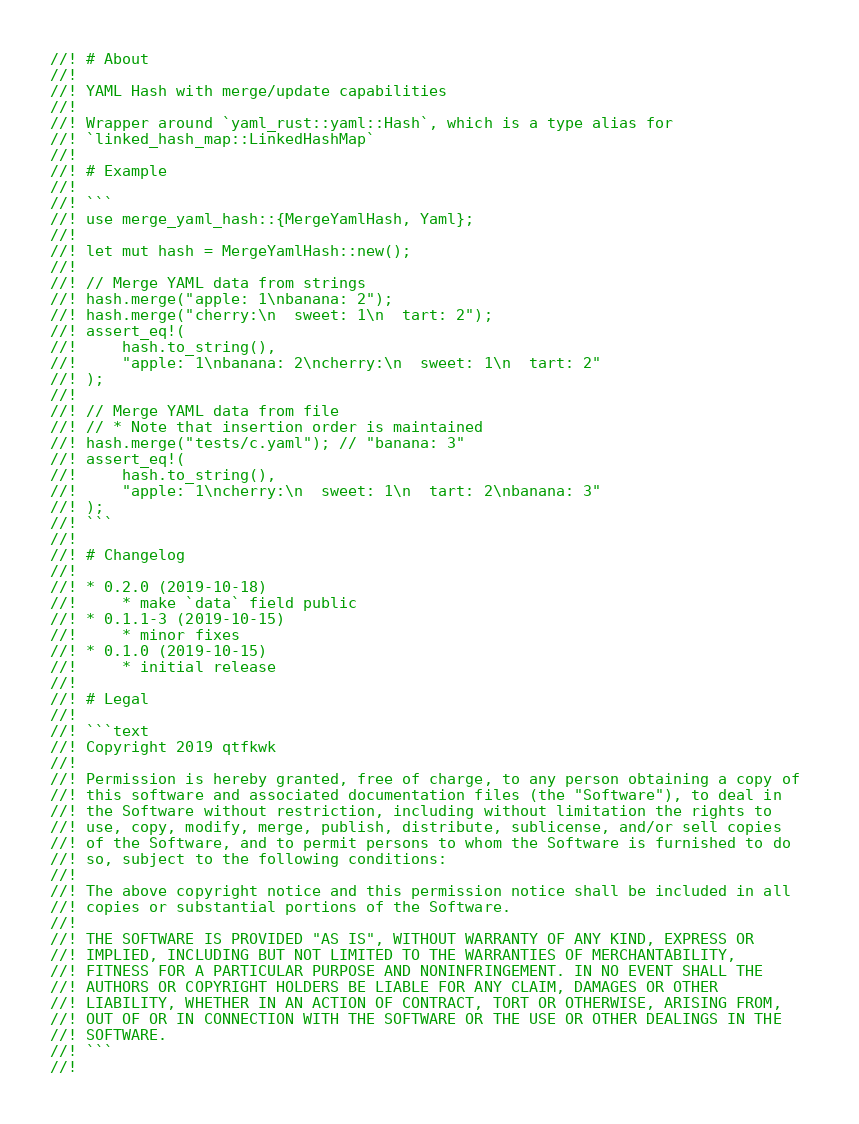Convert code to text. <code><loc_0><loc_0><loc_500><loc_500><_Rust_>//! # About
//! 
//! YAML Hash with merge/update capabilities
//! 
//! Wrapper around `yaml_rust::yaml::Hash`, which is a type alias for
//! `linked_hash_map::LinkedHashMap`
//! 
//! # Example
//! 
//! ```
//! use merge_yaml_hash::{MergeYamlHash, Yaml};
//! 
//! let mut hash = MergeYamlHash::new();
//! 
//! // Merge YAML data from strings
//! hash.merge("apple: 1\nbanana: 2");
//! hash.merge("cherry:\n  sweet: 1\n  tart: 2");
//! assert_eq!(
//!     hash.to_string(),
//!     "apple: 1\nbanana: 2\ncherry:\n  sweet: 1\n  tart: 2"
//! );
//! 
//! // Merge YAML data from file
//! // * Note that insertion order is maintained
//! hash.merge("tests/c.yaml"); // "banana: 3"
//! assert_eq!(
//!     hash.to_string(),
//!     "apple: 1\ncherry:\n  sweet: 1\n  tart: 2\nbanana: 3"
//! );
//! ```
//! 
//! # Changelog
//! 
//! * 0.2.0 (2019-10-18)
//!     * make `data` field public
//! * 0.1.1-3 (2019-10-15)
//!     * minor fixes
//! * 0.1.0 (2019-10-15)
//!     * initial release
//! 
//! # Legal
//! 
//! ```text
//! Copyright 2019 qtfkwk
//! 
//! Permission is hereby granted, free of charge, to any person obtaining a copy of 
//! this software and associated documentation files (the "Software"), to deal in 
//! the Software without restriction, including without limitation the rights to 
//! use, copy, modify, merge, publish, distribute, sublicense, and/or sell copies 
//! of the Software, and to permit persons to whom the Software is furnished to do 
//! so, subject to the following conditions:
//! 
//! The above copyright notice and this permission notice shall be included in all 
//! copies or substantial portions of the Software.
//! 
//! THE SOFTWARE IS PROVIDED "AS IS", WITHOUT WARRANTY OF ANY KIND, EXPRESS OR 
//! IMPLIED, INCLUDING BUT NOT LIMITED TO THE WARRANTIES OF MERCHANTABILITY, 
//! FITNESS FOR A PARTICULAR PURPOSE AND NONINFRINGEMENT. IN NO EVENT SHALL THE 
//! AUTHORS OR COPYRIGHT HOLDERS BE LIABLE FOR ANY CLAIM, DAMAGES OR OTHER 
//! LIABILITY, WHETHER IN AN ACTION OF CONTRACT, TORT OR OTHERWISE, ARISING FROM, 
//! OUT OF OR IN CONNECTION WITH THE SOFTWARE OR THE USE OR OTHER DEALINGS IN THE 
//! SOFTWARE.
//! ```
//! </code> 